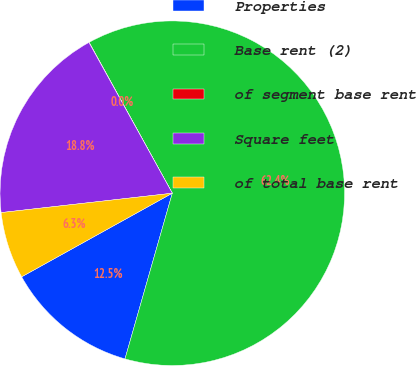<chart> <loc_0><loc_0><loc_500><loc_500><pie_chart><fcel>Properties<fcel>Base rent (2)<fcel>of segment base rent<fcel>Square feet<fcel>of total base rent<nl><fcel>12.51%<fcel>62.44%<fcel>0.03%<fcel>18.75%<fcel>6.27%<nl></chart> 